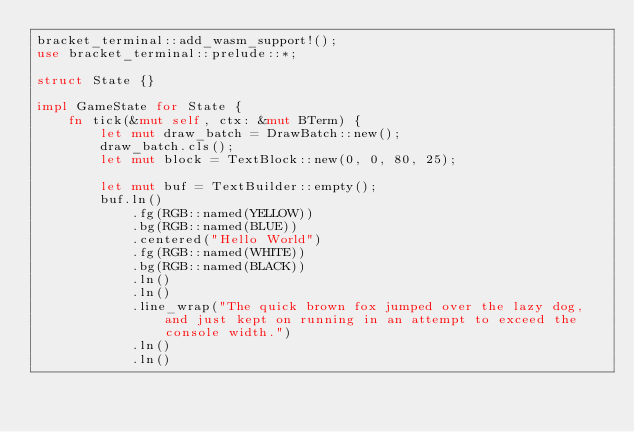Convert code to text. <code><loc_0><loc_0><loc_500><loc_500><_Rust_>bracket_terminal::add_wasm_support!();
use bracket_terminal::prelude::*;

struct State {}

impl GameState for State {
    fn tick(&mut self, ctx: &mut BTerm) {
        let mut draw_batch = DrawBatch::new();
        draw_batch.cls();
        let mut block = TextBlock::new(0, 0, 80, 25);

        let mut buf = TextBuilder::empty();
        buf.ln()
            .fg(RGB::named(YELLOW))
            .bg(RGB::named(BLUE))
            .centered("Hello World")
            .fg(RGB::named(WHITE))
            .bg(RGB::named(BLACK))
            .ln()
            .ln()
            .line_wrap("The quick brown fox jumped over the lazy dog, and just kept on running in an attempt to exceed the console width.")
            .ln()
            .ln()</code> 